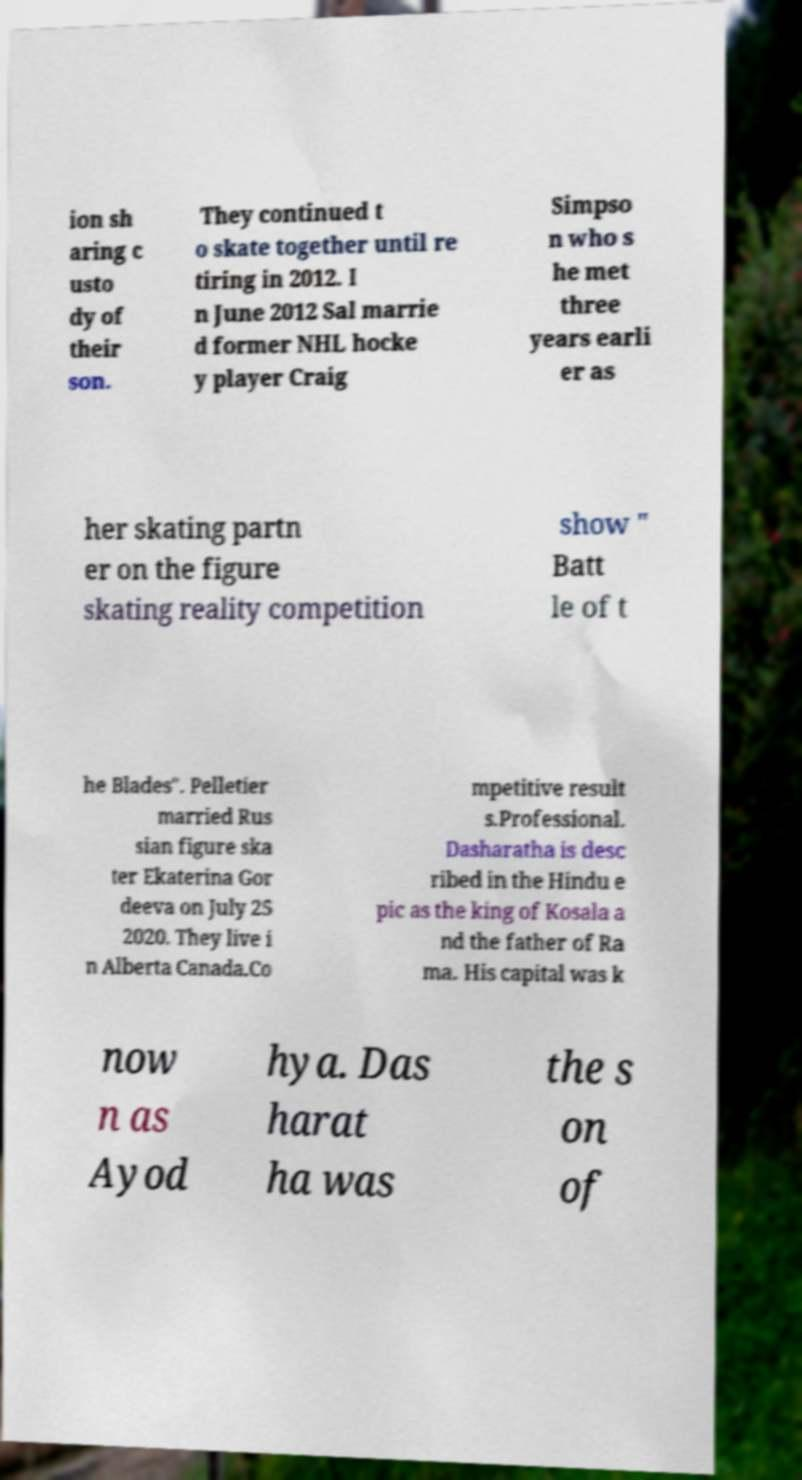Could you assist in decoding the text presented in this image and type it out clearly? ion sh aring c usto dy of their son. They continued t o skate together until re tiring in 2012. I n June 2012 Sal marrie d former NHL hocke y player Craig Simpso n who s he met three years earli er as her skating partn er on the figure skating reality competition show " Batt le of t he Blades". Pelletier married Rus sian figure ska ter Ekaterina Gor deeva on July 25 2020. They live i n Alberta Canada.Co mpetitive result s.Professional. Dasharatha is desc ribed in the Hindu e pic as the king of Kosala a nd the father of Ra ma. His capital was k now n as Ayod hya. Das harat ha was the s on of 